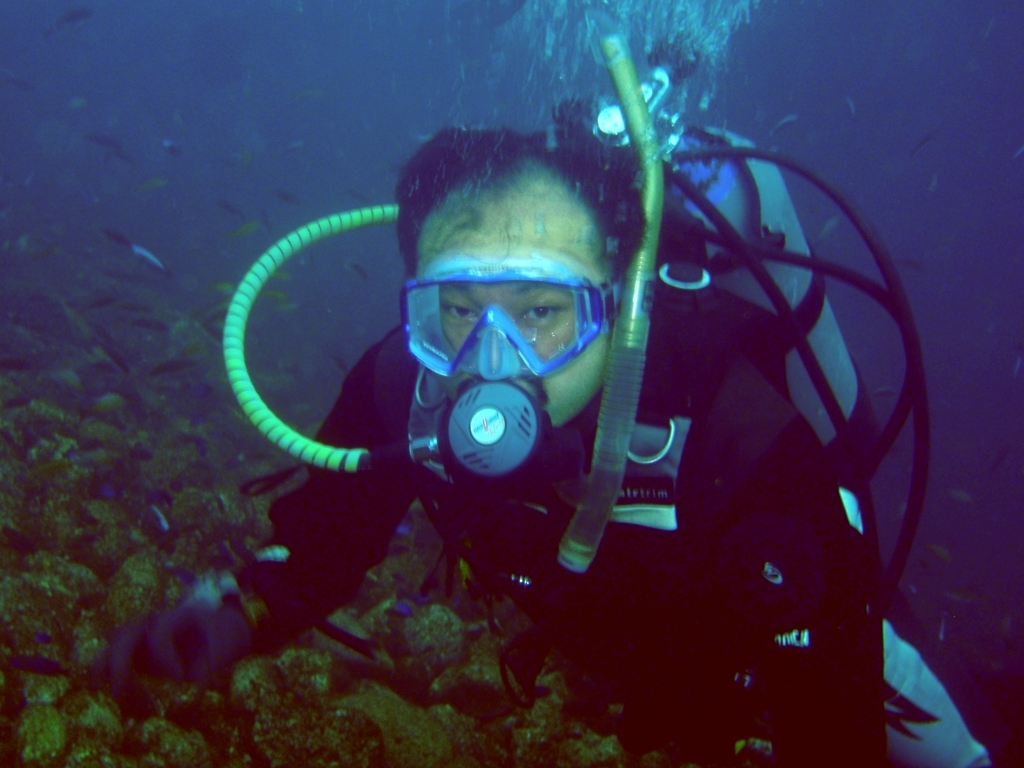What activity is depicted in this image? The image captures an individual engaged in scuba diving, exploring the marine environment underwater, equipped with a diving mask, snorkel, and scuba tank. Could you explain some key equipment used for this activity? Certainly! Key equipment for scuba diving includes the diving mask for clear vision underwater, a snorkel for breathing at the surface, a scuba tank containing compressed air, a regulator to control air flow, fins for efficient swimming, and a buoyancy control device (BCD) for maintaining desired depth. 